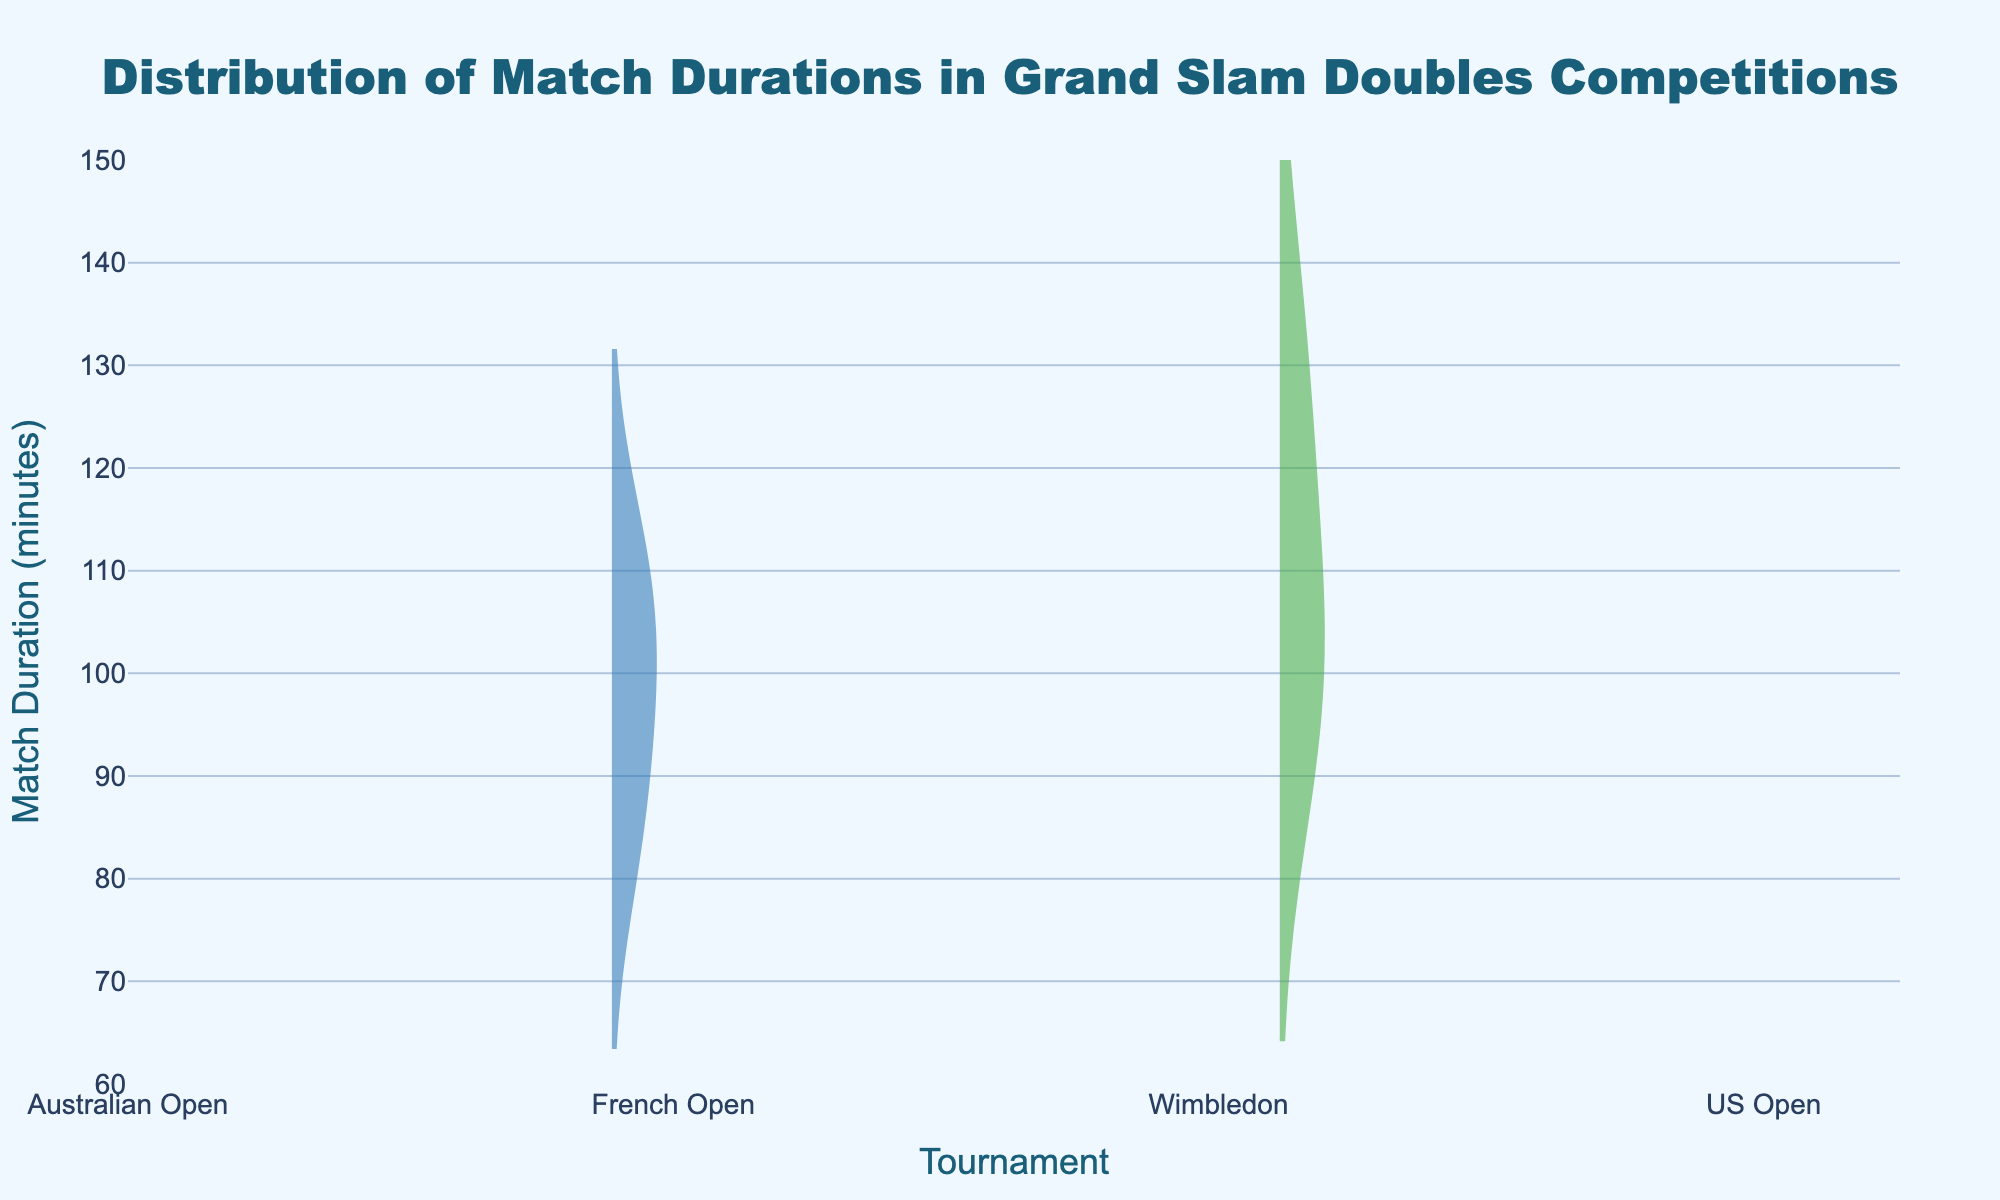What is the title of the figure? The title of any figure is usually present at the top and in larger font size. In this case, it is bold and highlighted.
Answer: Distribution of Match Durations in Grand Slam Doubles Competitions Which tournament has the longest match duration based on the data? By looking at the figure, identify the highest peak or the uppermost point on the y-axis within the violin plots for each tournament.
Answer: Australian Open What is the y-axis representing in this figure? The y-axis caption explains what the vertical measurement represents in a plot. Here, it indicates the duration of matches.
Answer: Match Duration (minutes) Which tournament has the lowest median match duration? The median value is usually marked by a line within the box of the violin plot. Check for the line that is lowest among the tournaments.
Answer: US Open What is the range of match durations for the Wimbledon tournament? Observing the spread of the violin plot and the edges of the corresponding box plot helps to determine the range. The smallest and largest values in the box plot denote the range.
Answer: 95 to 130 minutes Which tournament has the smallest interquartile range (IQR)? The interquartile range is the span between the first quartile (Q1) and the third quartile (Q3), shown by the width of the box within the plot. Find the smallest box plot width.
Answer: Wimbledon What is the average match duration in the French Open tournament? The average is depicted by a line in the violin plot. You need to locate this line within the French Open section.
Answer: Approximately 98 minutes Which tournament has the most symmetrical distribution of match durations? A symmetrical distribution would have a violin plot that is evenly spread on both sides around the peak. Identify the plot that looks least skewed.
Answer: Wimbledon Comparatively, which tournament shows a more varied distribution of match durations, Australian Open or US Open? A varied or wider distribution is indicated by a broader violin shape. Observe and compare the width of the plots for both tournaments.
Answer: Australian Open How does the distribution pattern for match durations at the French Open compare to the Wimbledon? A comparative analysis involves checking the spread, peaks, and symmetry of the violin shapes for both tournaments to note the variations.
Answer: French Open has a narrower spread and slightly skewed distribution compared to Wimbledon 